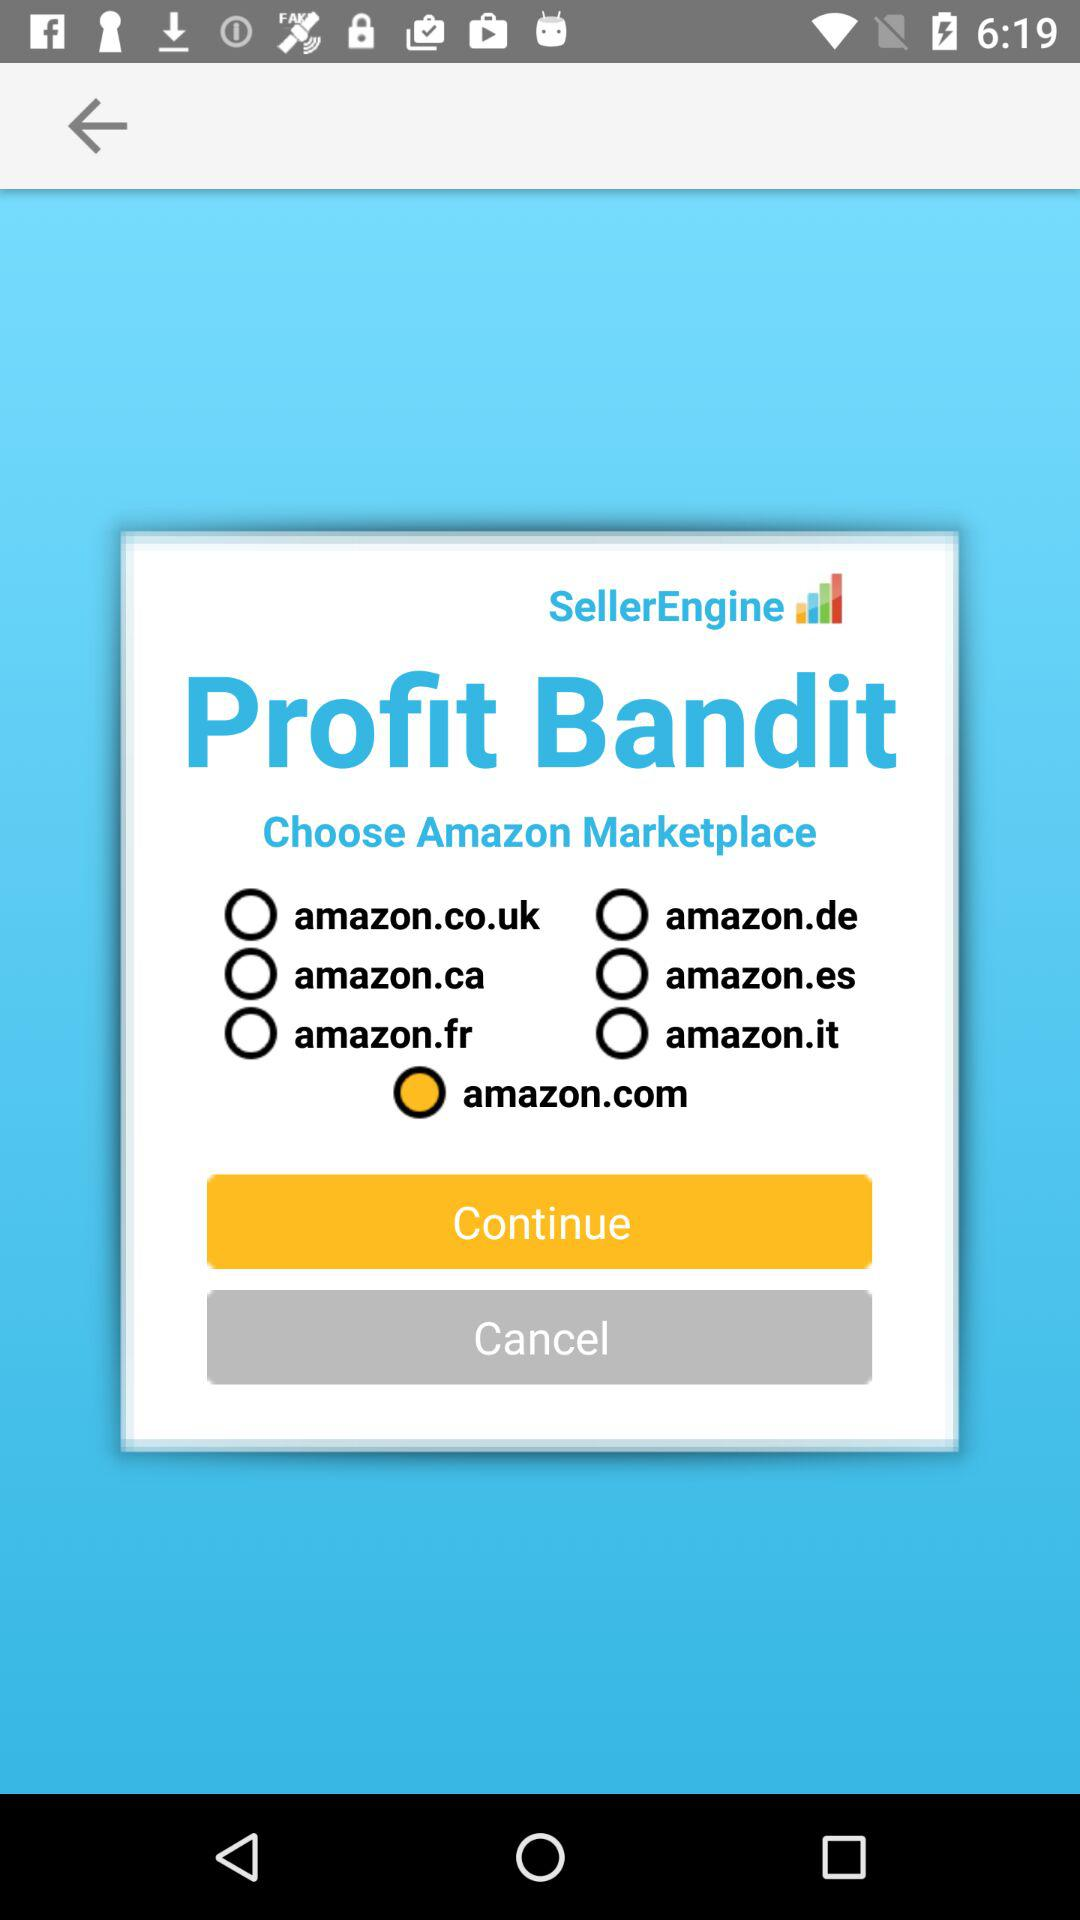What is the selected Amazon marketplace? The selected amazon marketplace is amazon.com. 